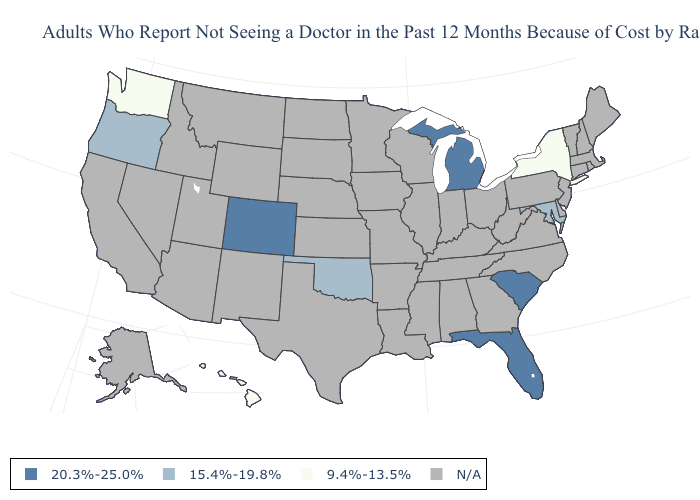Does Colorado have the highest value in the West?
Give a very brief answer. Yes. Does Colorado have the highest value in the USA?
Answer briefly. Yes. What is the value of Maine?
Quick response, please. N/A. Is the legend a continuous bar?
Be succinct. No. Does Maryland have the lowest value in the South?
Be succinct. Yes. Does the first symbol in the legend represent the smallest category?
Give a very brief answer. No. What is the value of Pennsylvania?
Concise answer only. N/A. What is the lowest value in the USA?
Short answer required. 9.4%-13.5%. Does Hawaii have the highest value in the USA?
Concise answer only. No. Name the states that have a value in the range 15.4%-19.8%?
Answer briefly. Maryland, Oklahoma, Oregon. What is the value of Vermont?
Concise answer only. N/A. Name the states that have a value in the range 9.4%-13.5%?
Quick response, please. Hawaii, New York, Washington. Name the states that have a value in the range 20.3%-25.0%?
Be succinct. Colorado, Florida, Michigan, South Carolina. 